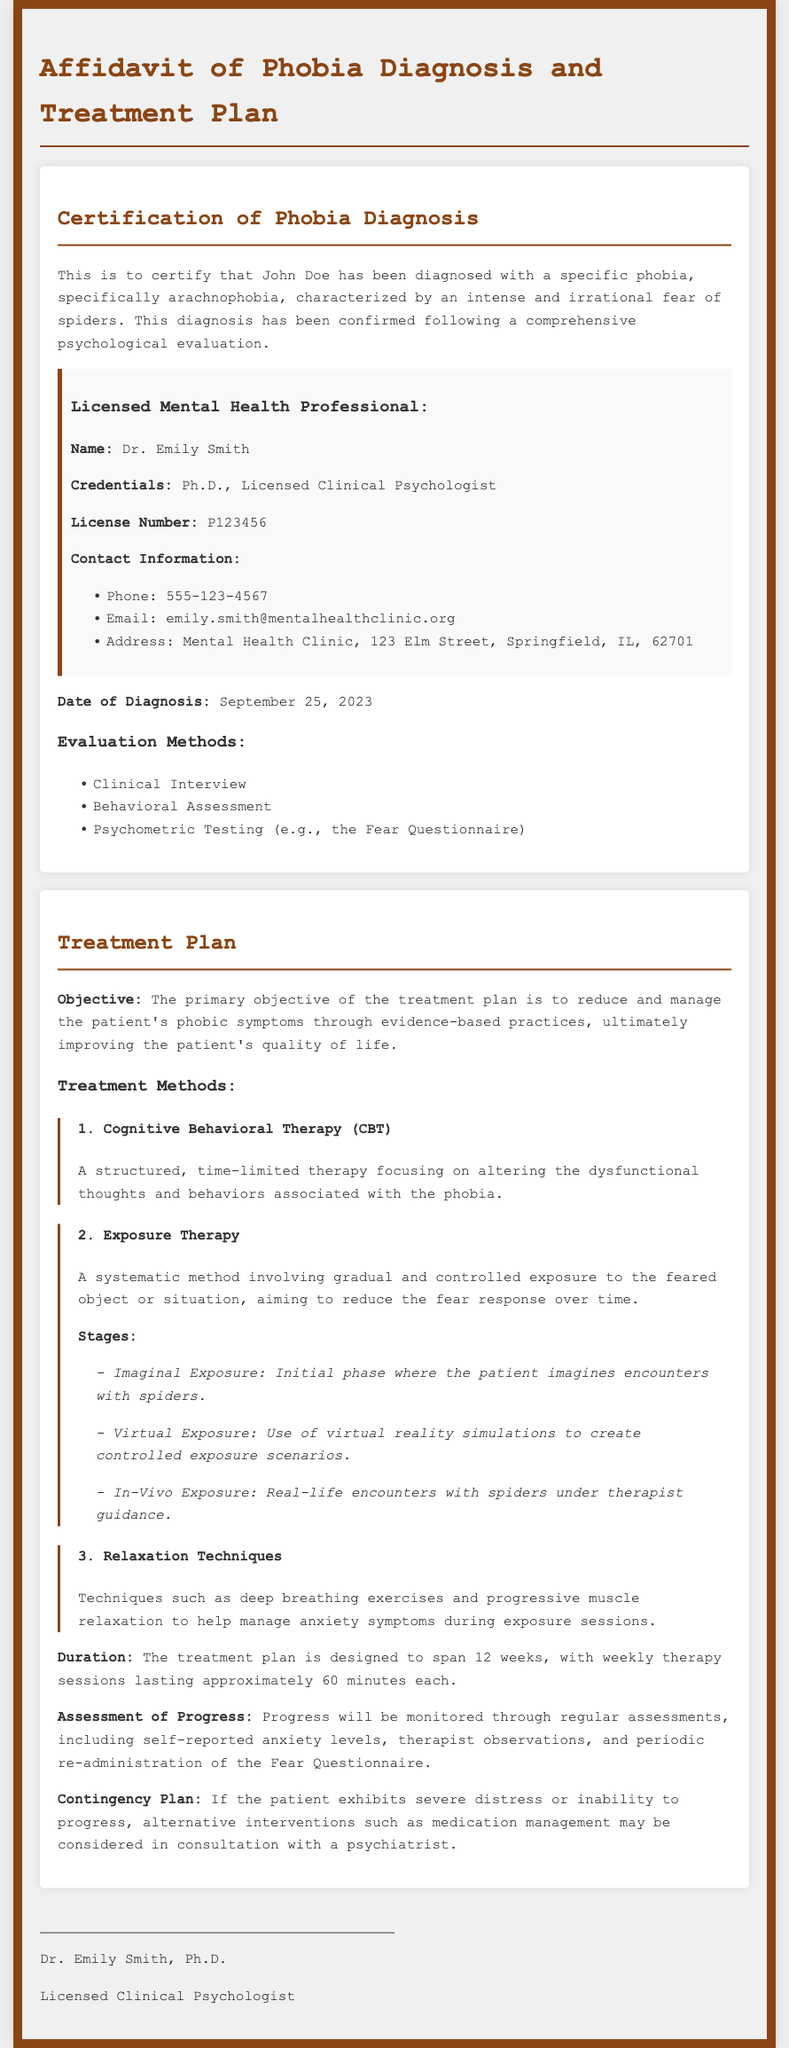what phobia is diagnosed? The document specifically states the phobia diagnosed is arachnophobia, which is an intense and irrational fear of spiders.
Answer: arachnophobia who conducted the evaluation? The licensed mental health professional who conducted the evaluation is mentioned in the document as Dr. Emily Smith.
Answer: Dr. Emily Smith what is the primary objective of the treatment plan? The primary objective stated in the document is to reduce and manage the patient's phobic symptoms through evidence-based practices.
Answer: reduce and manage phobic symptoms what type of therapy is listed first in the treatment methods? The first therapy mentioned in the treatment methods is Cognitive Behavioral Therapy (CBT).
Answer: Cognitive Behavioral Therapy (CBT) how many stages are involved in Exposure Therapy? The document outlines three stages involved in Exposure Therapy.
Answer: three when was the diagnosis made? The date of diagnosis provided in the document is September 25, 2023.
Answer: September 25, 2023 what is the total duration of the treatment plan? The treatment plan is designed to span 12 weeks as indicated in the document.
Answer: 12 weeks what will progress be monitored through? The document lists regular assessments, including self-reported anxiety levels and therapist observations, as methods for monitoring progress.
Answer: regular assessments what techniques are mentioned for managing anxiety symptoms? Techniques mentioned for managing anxiety symptoms include deep breathing exercises and progressive muscle relaxation.
Answer: deep breathing exercises and progressive muscle relaxation 